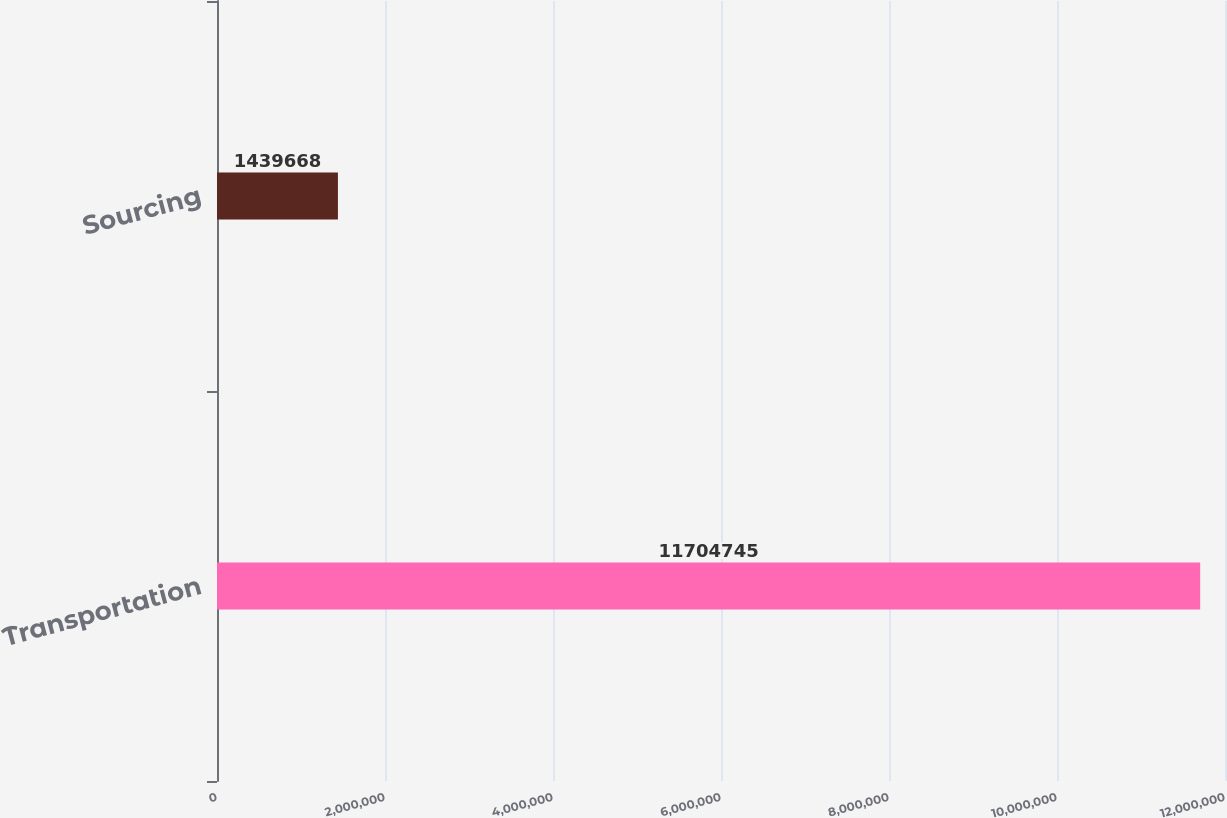Convert chart. <chart><loc_0><loc_0><loc_500><loc_500><bar_chart><fcel>Transportation<fcel>Sourcing<nl><fcel>1.17047e+07<fcel>1.43967e+06<nl></chart> 